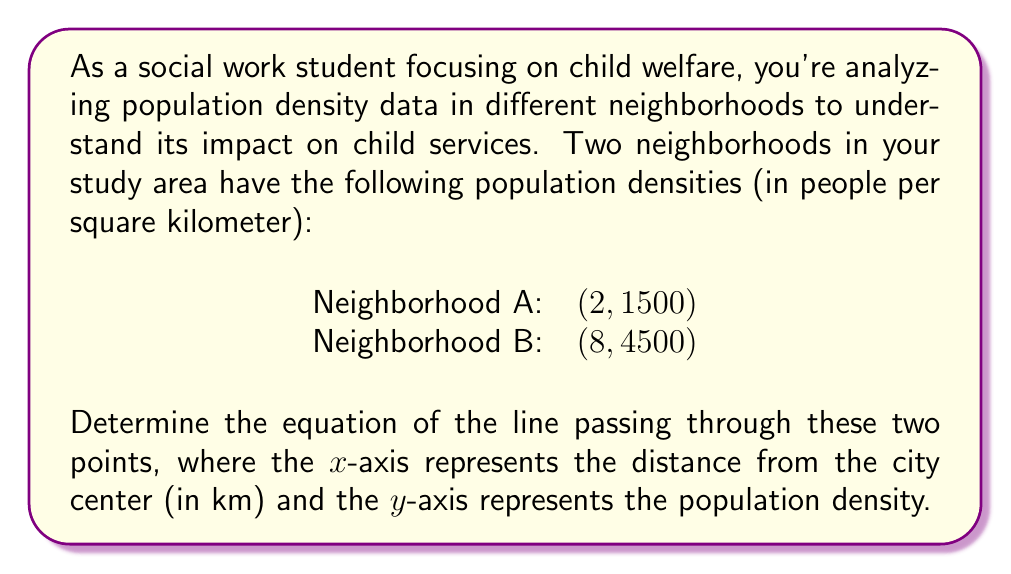Solve this math problem. To find the equation of a line passing through two points, we can use the point-slope form of a line: $y - y_1 = m(x - x_1)$, where $m$ is the slope of the line.

Step 1: Calculate the slope $(m)$ using the two given points.
$m = \frac{y_2 - y_1}{x_2 - x_1} = \frac{4500 - 1500}{8 - 2} = \frac{3000}{6} = 500$

Step 2: Choose one of the points to use in the point-slope form. Let's use $(2, 1500)$.

Step 3: Substitute the slope and the chosen point into the point-slope form:
$y - 1500 = 500(x - 2)$

Step 4: Distribute the 500:
$y - 1500 = 500x - 1000$

Step 5: Add 1500 to both sides to isolate $y$:
$y = 500x - 1000 + 1500$

Step 6: Simplify:
$y = 500x + 500$

This equation represents the line passing through the two given points, where $y$ is the population density and $x$ is the distance from the city center in kilometers.
Answer: $y = 500x + 500$ 